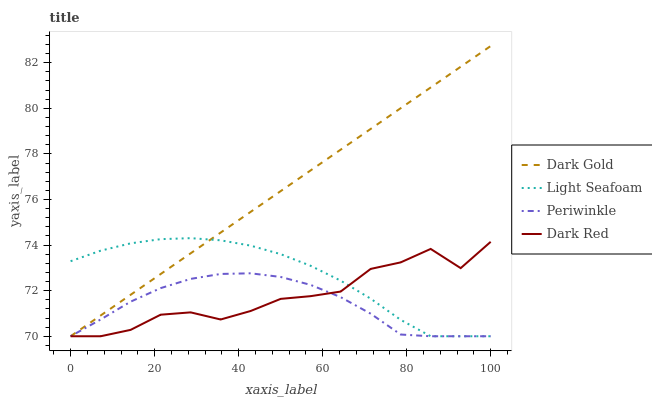Does Periwinkle have the minimum area under the curve?
Answer yes or no. Yes. Does Dark Gold have the maximum area under the curve?
Answer yes or no. Yes. Does Light Seafoam have the minimum area under the curve?
Answer yes or no. No. Does Light Seafoam have the maximum area under the curve?
Answer yes or no. No. Is Dark Gold the smoothest?
Answer yes or no. Yes. Is Dark Red the roughest?
Answer yes or no. Yes. Is Light Seafoam the smoothest?
Answer yes or no. No. Is Light Seafoam the roughest?
Answer yes or no. No. Does Dark Red have the lowest value?
Answer yes or no. Yes. Does Dark Gold have the highest value?
Answer yes or no. Yes. Does Light Seafoam have the highest value?
Answer yes or no. No. Does Dark Gold intersect Light Seafoam?
Answer yes or no. Yes. Is Dark Gold less than Light Seafoam?
Answer yes or no. No. Is Dark Gold greater than Light Seafoam?
Answer yes or no. No. 